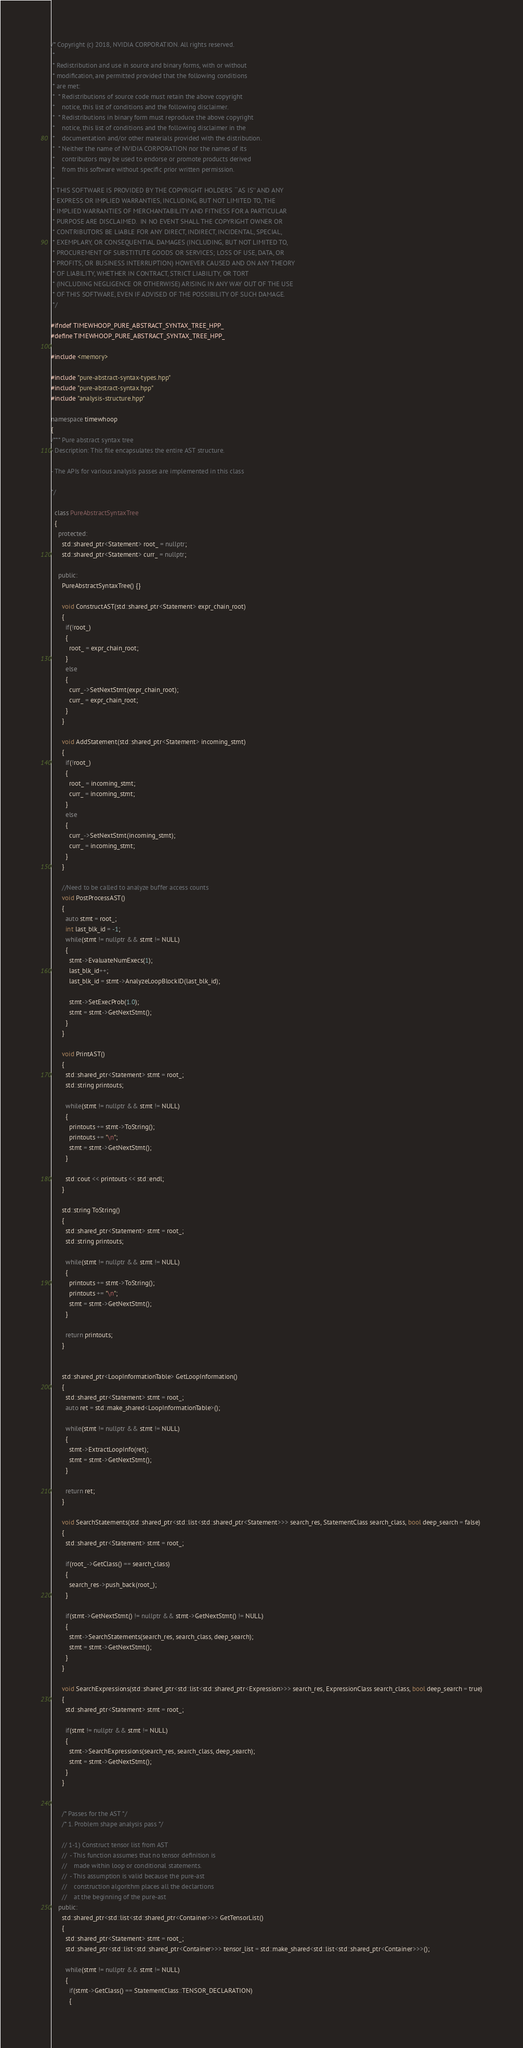Convert code to text. <code><loc_0><loc_0><loc_500><loc_500><_C++_>/* Copyright (c) 2018, NVIDIA CORPORATION. All rights reserved.
 *
 * Redistribution and use in source and binary forms, with or without
 * modification, are permitted provided that the following conditions
 * are met:
 *  * Redistributions of source code must retain the above copyright
 *    notice, this list of conditions and the following disclaimer.
 *  * Redistributions in binary form must reproduce the above copyright
 *    notice, this list of conditions and the following disclaimer in the
 *    documentation and/or other materials provided with the distribution.
 *  * Neither the name of NVIDIA CORPORATION nor the names of its
 *    contributors may be used to endorse or promote products derived
 *    from this software without specific prior written permission.
 *
 * THIS SOFTWARE IS PROVIDED BY THE COPYRIGHT HOLDERS ``AS IS'' AND ANY
 * EXPRESS OR IMPLIED WARRANTIES, INCLUDING, BUT NOT LIMITED TO, THE
 * IMPLIED WARRANTIES OF MERCHANTABILITY AND FITNESS FOR A PARTICULAR
 * PURPOSE ARE DISCLAIMED.  IN NO EVENT SHALL THE COPYRIGHT OWNER OR
 * CONTRIBUTORS BE LIABLE FOR ANY DIRECT, INDIRECT, INCIDENTAL, SPECIAL,
 * EXEMPLARY, OR CONSEQUENTIAL DAMAGES (INCLUDING, BUT NOT LIMITED TO,
 * PROCUREMENT OF SUBSTITUTE GOODS OR SERVICES; LOSS OF USE, DATA, OR
 * PROFITS; OR BUSINESS INTERRUPTION) HOWEVER CAUSED AND ON ANY THEORY
 * OF LIABILITY, WHETHER IN CONTRACT, STRICT LIABILITY, OR TORT
 * (INCLUDING NEGLIGENCE OR OTHERWISE) ARISING IN ANY WAY OUT OF THE USE
 * OF THIS SOFTWARE, EVEN IF ADVISED OF THE POSSIBILITY OF SUCH DAMAGE.
 */

#ifndef TIMEWHOOP_PURE_ABSTRACT_SYNTAX_TREE_HPP_
#define TIMEWHOOP_PURE_ABSTRACT_SYNTAX_TREE_HPP_

#include <memory>

#include "pure-abstract-syntax-types.hpp"
#include "pure-abstract-syntax.hpp"
#include "analysis-structure.hpp"

namespace timewhoop
{
/*** Pure abstract syntax tree
- Description: This file encapsulates the entire AST structure.

- The APIs for various analysis passes are implemented in this class

*/

  class PureAbstractSyntaxTree
  {
    protected:
	  std::shared_ptr<Statement> root_ = nullptr;
      std::shared_ptr<Statement> curr_ = nullptr;

    public:
      PureAbstractSyntaxTree() {}

      void ConstructAST(std::shared_ptr<Statement> expr_chain_root)
      {
        if(!root_)
        {
          root_ = expr_chain_root;
        }
        else
        {
          curr_->SetNextStmt(expr_chain_root);
          curr_ = expr_chain_root;
        }
      }

      void AddStatement(std::shared_ptr<Statement> incoming_stmt)
      {
        if(!root_)
        {
          root_ = incoming_stmt;
          curr_ = incoming_stmt;
        }
        else
        {
          curr_->SetNextStmt(incoming_stmt);
          curr_ = incoming_stmt;
        }
      }

      //Need to be called to analyze buffer access counts
      void PostProcessAST()
      {
        auto stmt = root_;
        int last_blk_id = -1;
        while(stmt != nullptr && stmt != NULL)
        {
          stmt->EvaluateNumExecs(1);
          last_blk_id++;
          last_blk_id = stmt->AnalyzeLoopBlockID(last_blk_id);

          stmt->SetExecProb(1.0);
          stmt = stmt->GetNextStmt();
        }
      }

      void PrintAST()
      {
        std::shared_ptr<Statement> stmt = root_;
        std::string printouts;

        while(stmt != nullptr && stmt != NULL)
        {
          printouts += stmt->ToString();
          printouts += "\n";
          stmt = stmt->GetNextStmt();
        }

        std::cout << printouts << std::endl;
      }

      std::string ToString()
      {
        std::shared_ptr<Statement> stmt = root_;
        std::string printouts;

        while(stmt != nullptr && stmt != NULL)
        {
          printouts += stmt->ToString();
          printouts += "\n";
          stmt = stmt->GetNextStmt();
        }

        return printouts;
      }


      std::shared_ptr<LoopInformationTable> GetLoopInformation()
      {
        std::shared_ptr<Statement> stmt = root_;
        auto ret = std::make_shared<LoopInformationTable>();

        while(stmt != nullptr && stmt != NULL)
        {
          stmt->ExtractLoopInfo(ret);
          stmt = stmt->GetNextStmt();
        }

        return ret;
      }

      void SearchStatements(std::shared_ptr<std::list<std::shared_ptr<Statement>>> search_res, StatementClass search_class, bool deep_search = false)
      {
        std::shared_ptr<Statement> stmt = root_;

        if(root_->GetClass() == search_class)
        {
          search_res->push_back(root_);
        }

        if(stmt->GetNextStmt() != nullptr && stmt->GetNextStmt() != NULL)
        {
          stmt->SearchStatements(search_res, search_class, deep_search);
          stmt = stmt->GetNextStmt();
        }
      }

      void SearchExpressions(std::shared_ptr<std::list<std::shared_ptr<Expression>>> search_res, ExpressionClass search_class, bool deep_search = true)
      {
        std::shared_ptr<Statement> stmt = root_;

        if(stmt != nullptr && stmt != NULL)
        {
          stmt->SearchExpressions(search_res, search_class, deep_search);
          stmt = stmt->GetNextStmt();
        }
      }


      /* Passes for the AST */
      /* 1. Problem shape analysis pass */

      // 1-1) Construct tensor list from AST
      //  - This function assumes that no tensor definition is 
      //    made within loop or conditional statements.
      //  - This assumption is valid because the pure-ast 
      //    construction algorithm places all the declartions 
      //    at the beginning of the pure-ast
    public:
      std::shared_ptr<std::list<std::shared_ptr<Container>>> GetTensorList()
      {
        std::shared_ptr<Statement> stmt = root_;
        std::shared_ptr<std::list<std::shared_ptr<Container>>> tensor_list = std::make_shared<std::list<std::shared_ptr<Container>>>(); 

        while(stmt != nullptr && stmt != NULL)
        {
          if(stmt->GetClass() == StatementClass::TENSOR_DECLARATION)
          {</code> 